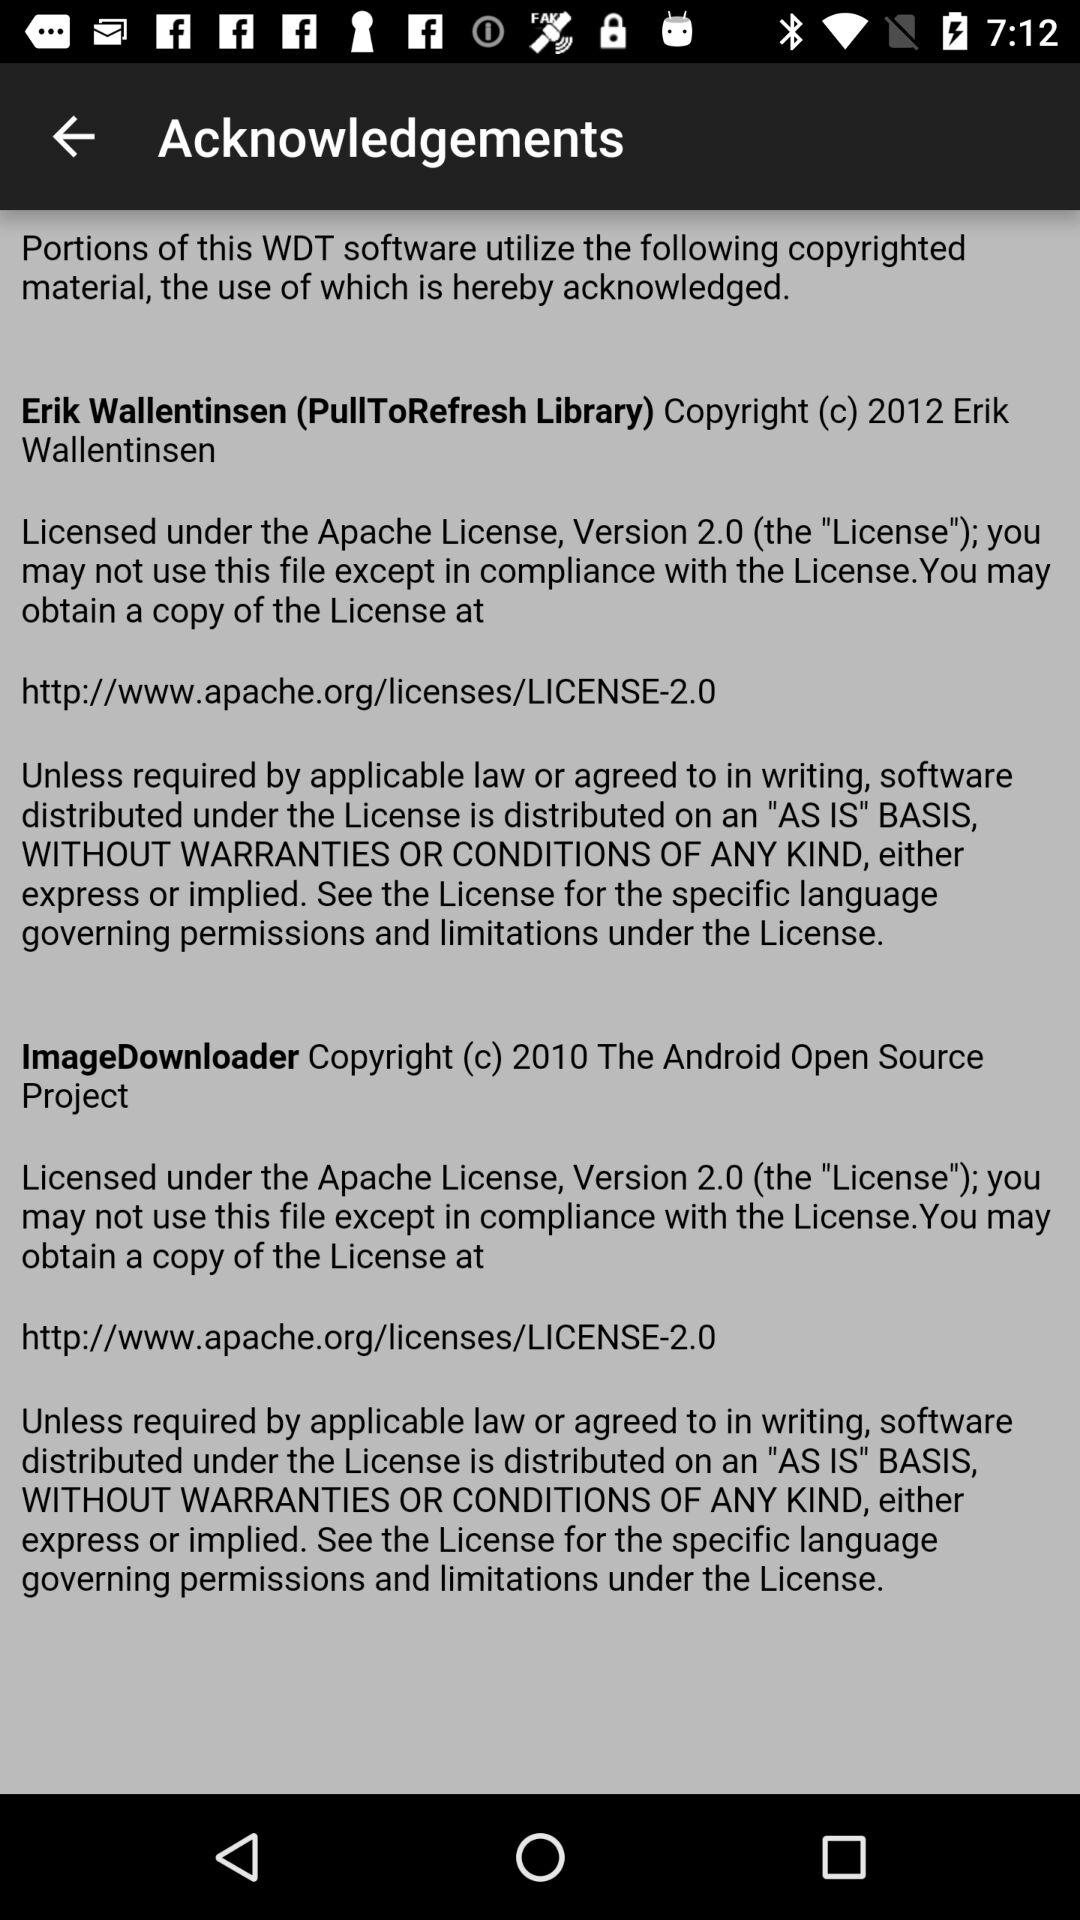How many different copyright holders are acknowledged?
Answer the question using a single word or phrase. 2 